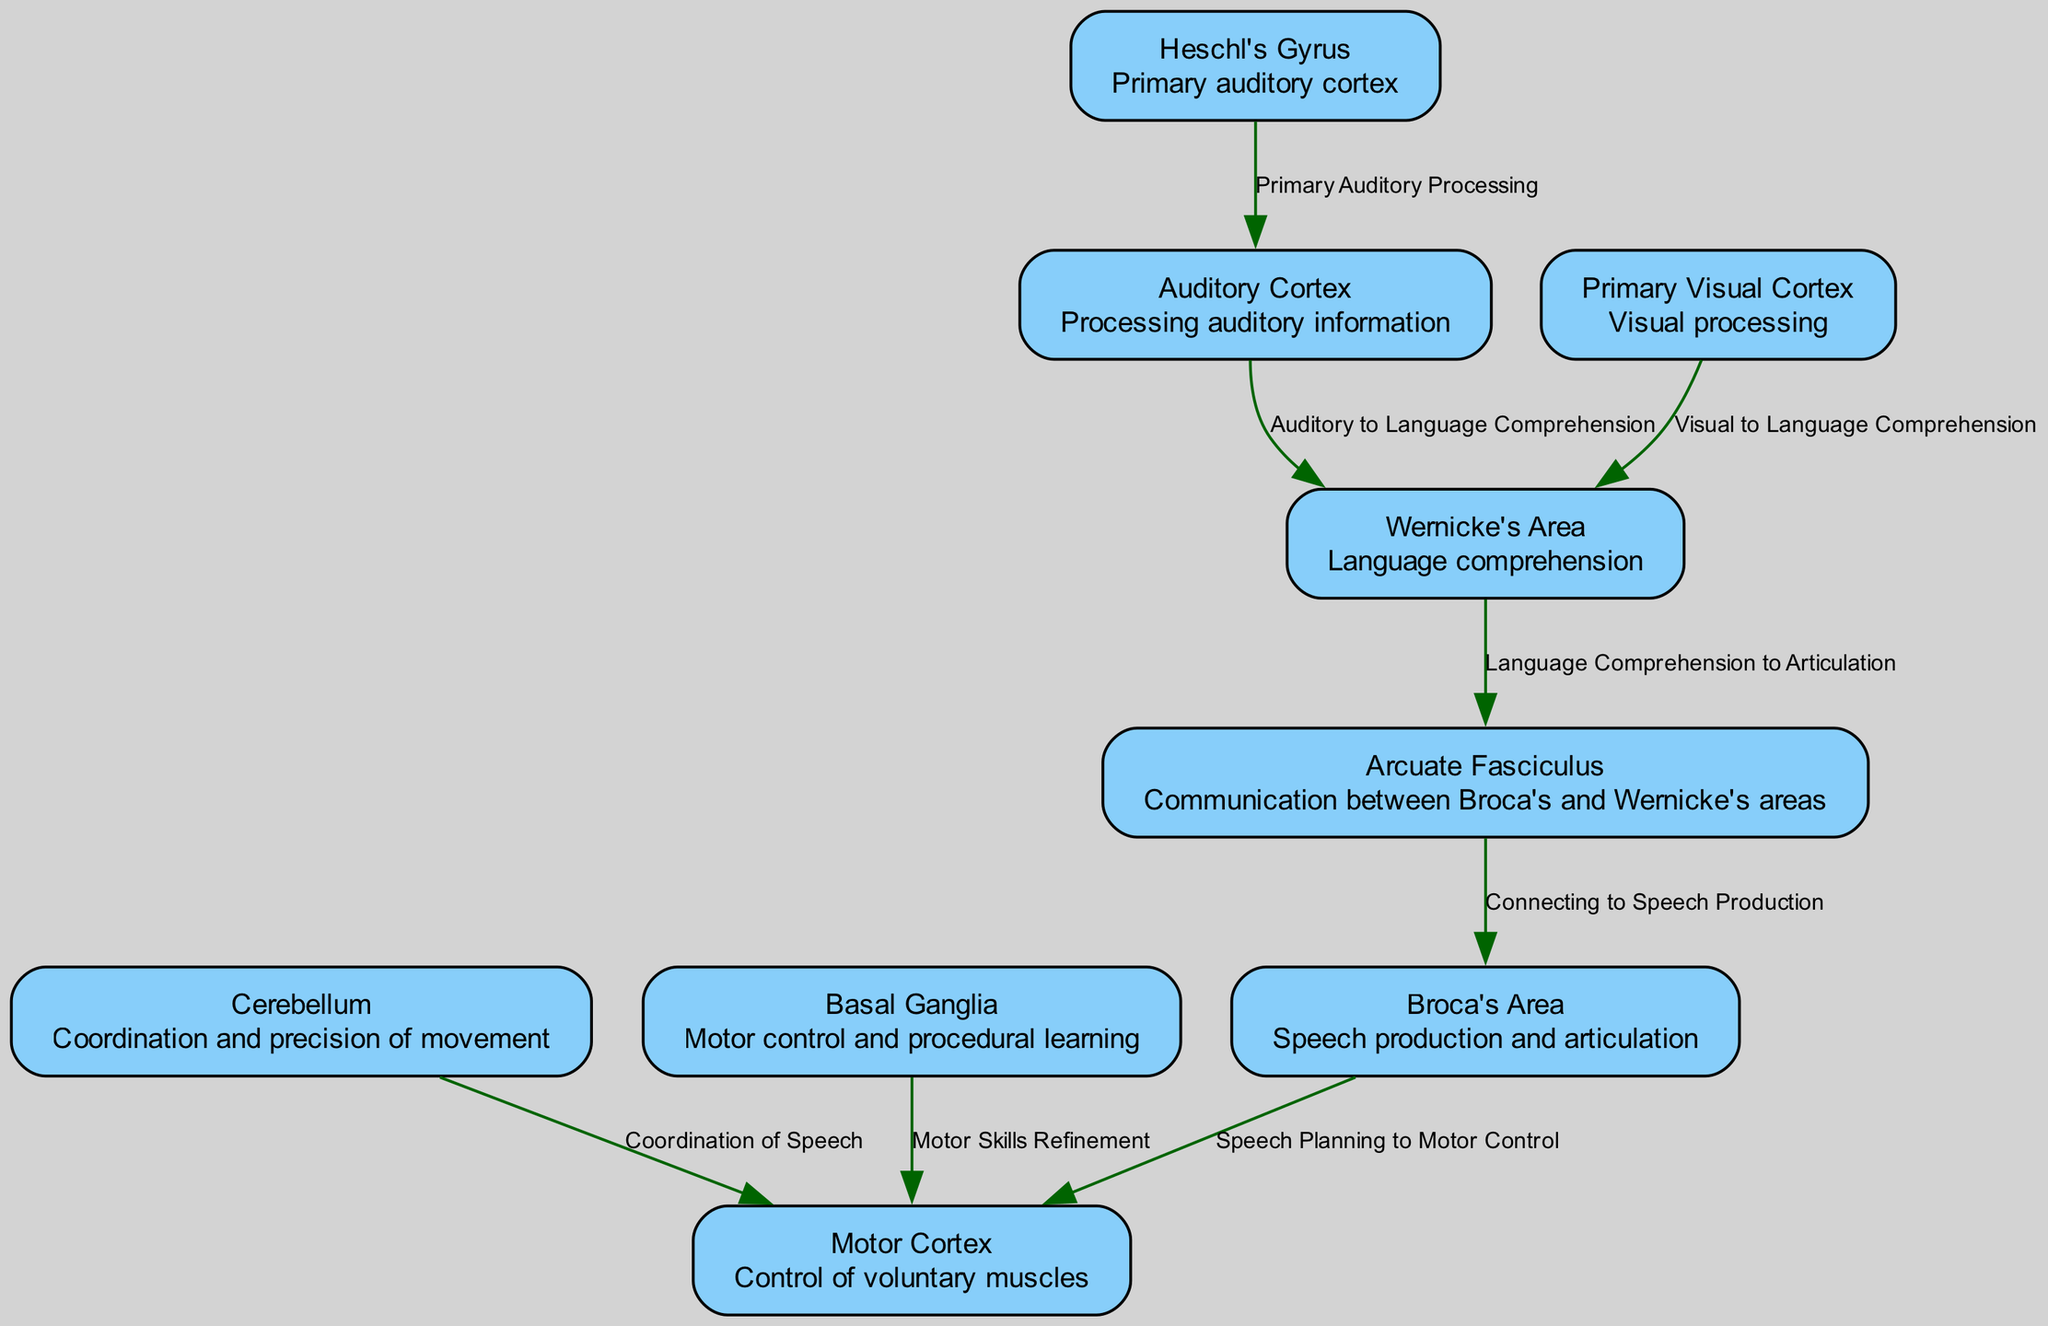What is the role of Broca's Area? Broca's Area is labeled in the diagram as involved in speech production and articulation, indicating its primary function in producing spoken language.
Answer: Speech production and articulation How many nodes are present in the diagram? By counting the individual node entries in the provided data, we find a total of eight distinct nodes representing various areas involved in speech and language processing.
Answer: 8 Which node connects Wernicke's Area to Broca's Area? The Arcuate Fasciculus is shown in the diagram as the connecting pathway between Wernicke's Area (language comprehension) and Broca's Area (speech production).
Answer: Arcuate Fasciculus What function does the Auditory Cortex serve? The diagram indicates that the Auditory Cortex processes auditory information, which is crucial for understanding spoken language and accents.
Answer: Processing auditory information Describe the flow from Auditory Cortex to Motor Cortex. The flow begins at the Auditory Cortex, where auditory information is processed and sent to Wernicke's Area for language comprehension. From there, the Arcuate Fasciculus connects to Broca's Area, which plans the speech and sends signals to the Motor Cortex for motor control related to speech.
Answer: Auditory Cortex -> Wernicke's Area -> Arcuate Fasciculus -> Broca's Area -> Motor Cortex What is the relationship between the Cerebellum and Motor Cortex in the context of speech? The diagram illustrates that the Cerebellum coordinates and refines the movements initiated in the Motor Cortex, enhancing precision and coordination in speech production.
Answer: Coordination of Speech Which node is directly responsible for language comprehension? Wernicke's Area is explicitly stated in the diagram as the area responsible for understanding language, making it the central node for this function.
Answer: Wernicke's Area How does the Primary Visual Cortex relate to Wernicke's Area? The flow from the Primary Visual Cortex to Wernicke's Area indicates that visual inputs can aid in language comprehension, suggesting an interconnection between visual and language processing.
Answer: Visual to Language Comprehension 